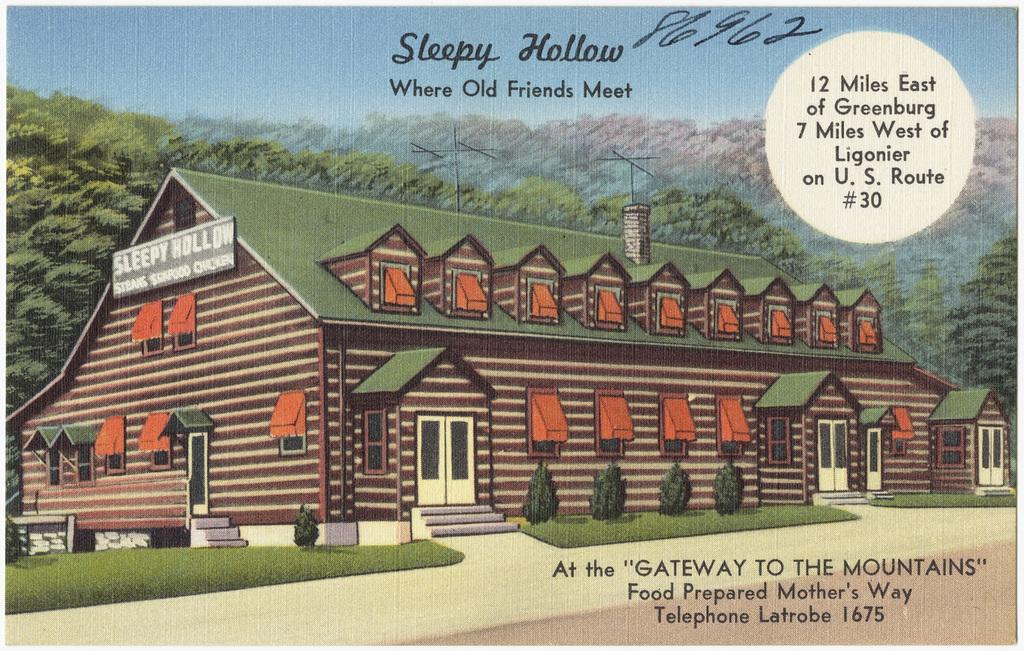What is featured on the poster in the image? The poster contains an image of a building, grass, and plants. What is on the building in the poster? There is a board on the building in the poster. What can be seen in the background of the image? There are trees and the sky visible in the background of the image. What is present in the image besides the poster? There is text present in the image. Can you tell me how many hills are visible in the image? There are no hills visible in the image; it features a poster with an image of a building, grass, and plants, as well as trees and the sky in the background. 